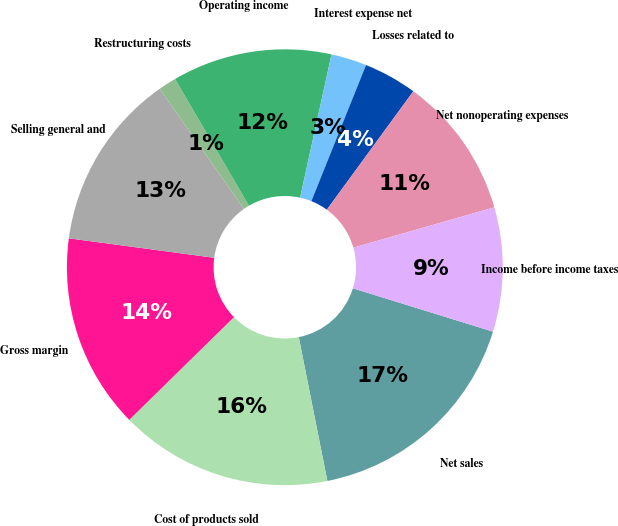Convert chart to OTSL. <chart><loc_0><loc_0><loc_500><loc_500><pie_chart><fcel>Net sales<fcel>Cost of products sold<fcel>Gross margin<fcel>Selling general and<fcel>Restructuring costs<fcel>Operating income<fcel>Interest expense net<fcel>Losses related to<fcel>Net nonoperating expenses<fcel>Income before income taxes<nl><fcel>17.1%<fcel>15.78%<fcel>14.47%<fcel>13.15%<fcel>1.33%<fcel>11.84%<fcel>2.64%<fcel>3.96%<fcel>10.53%<fcel>9.21%<nl></chart> 